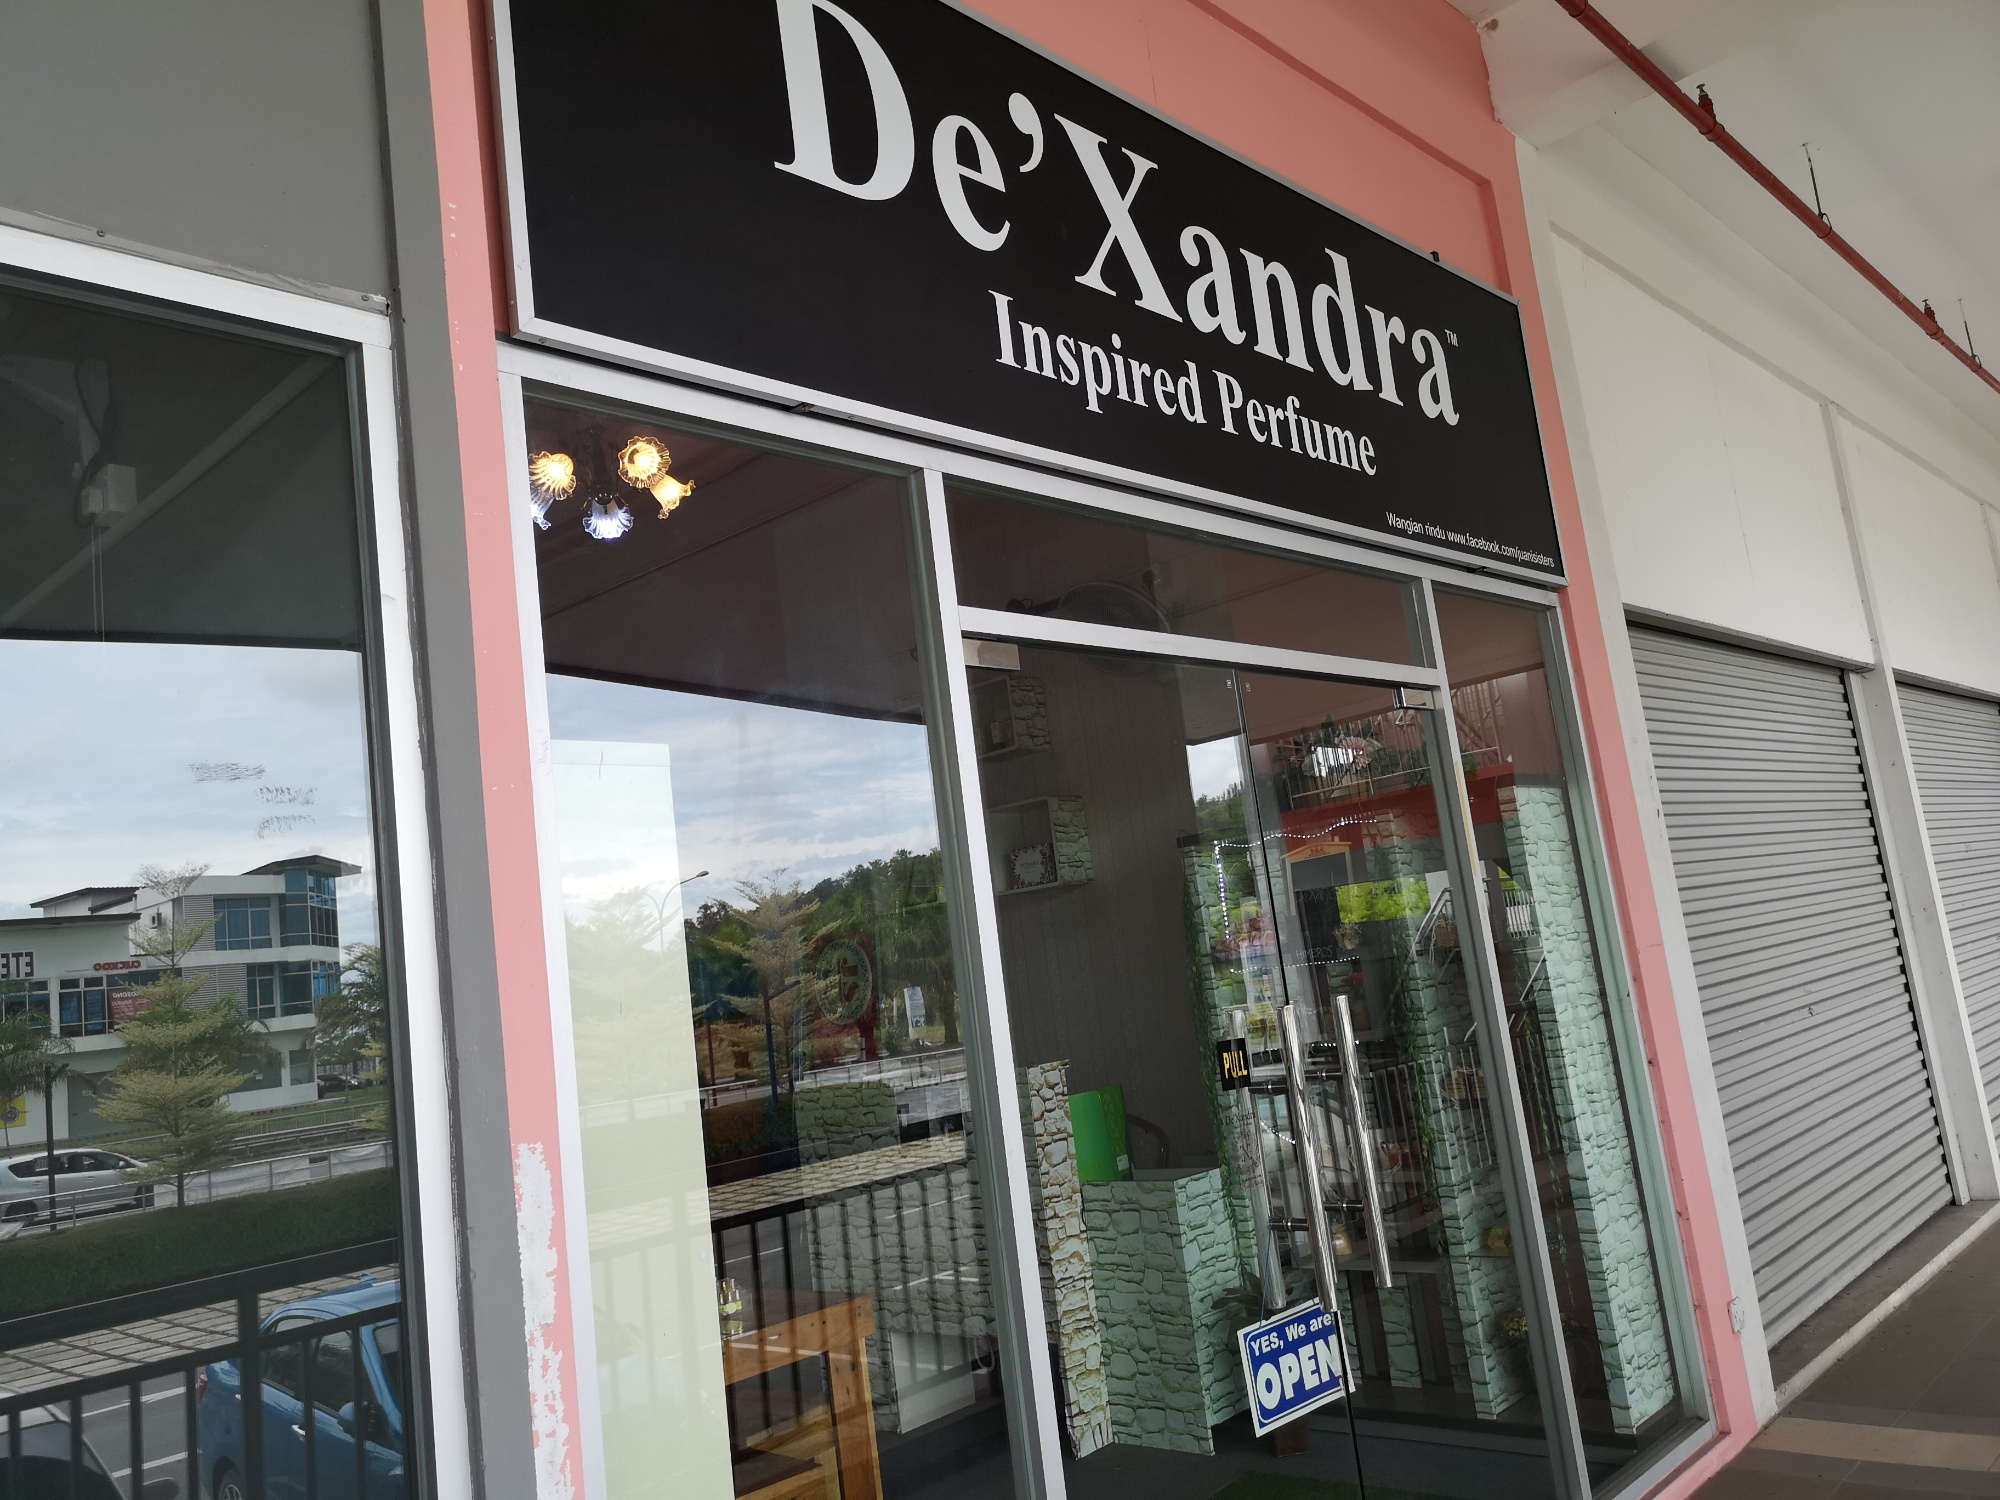If you were to write a story about the store, what exciting plot could you create involving the perfumes sold here? Once upon a time, in the tranquil mall where De'Xandra Inspired Perfume stood, each fragrance bottled a memory from a different era. When a customer purchased a bottle, they could relive that era for a day. A young historian stumbled upon this secret and began a thrilling journey across time, uncovering lost civilizations and pivotal moments in history. Along the way, they met various allies and villains from different times, each drawn to the mysterious powers of these perfumes. The plot would twist around their quest to protect the perfumes from falling into the wrong hands and preserve history as it should be. 